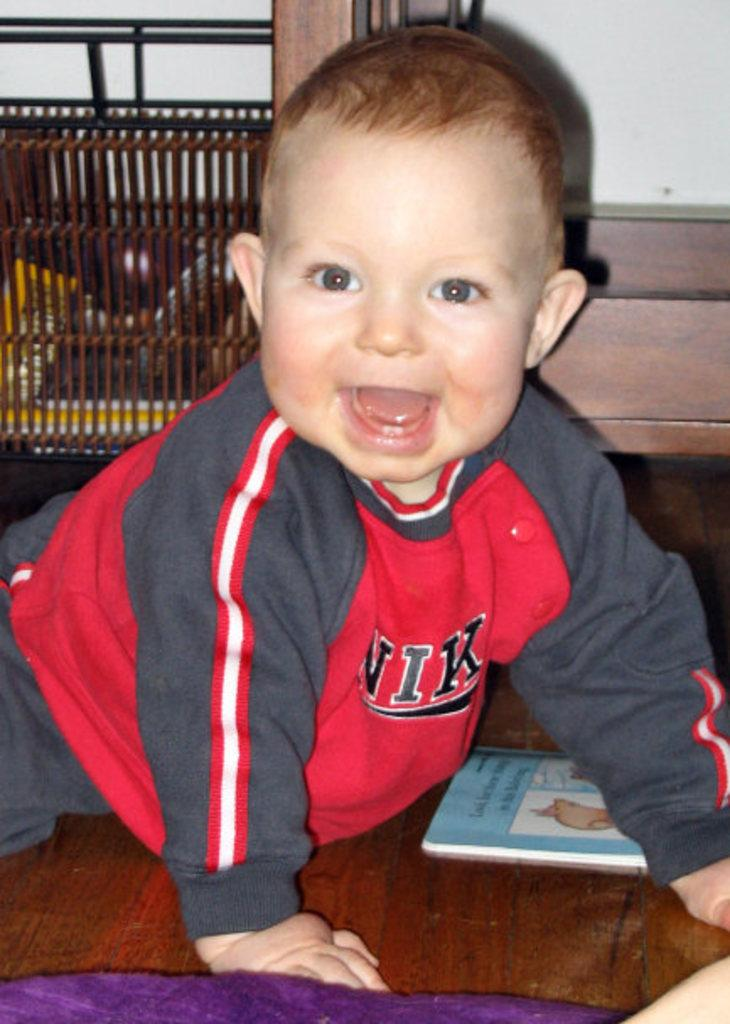Provide a one-sentence caption for the provided image. A small child wearing a Nike sweatshirt crawls across the floor. 